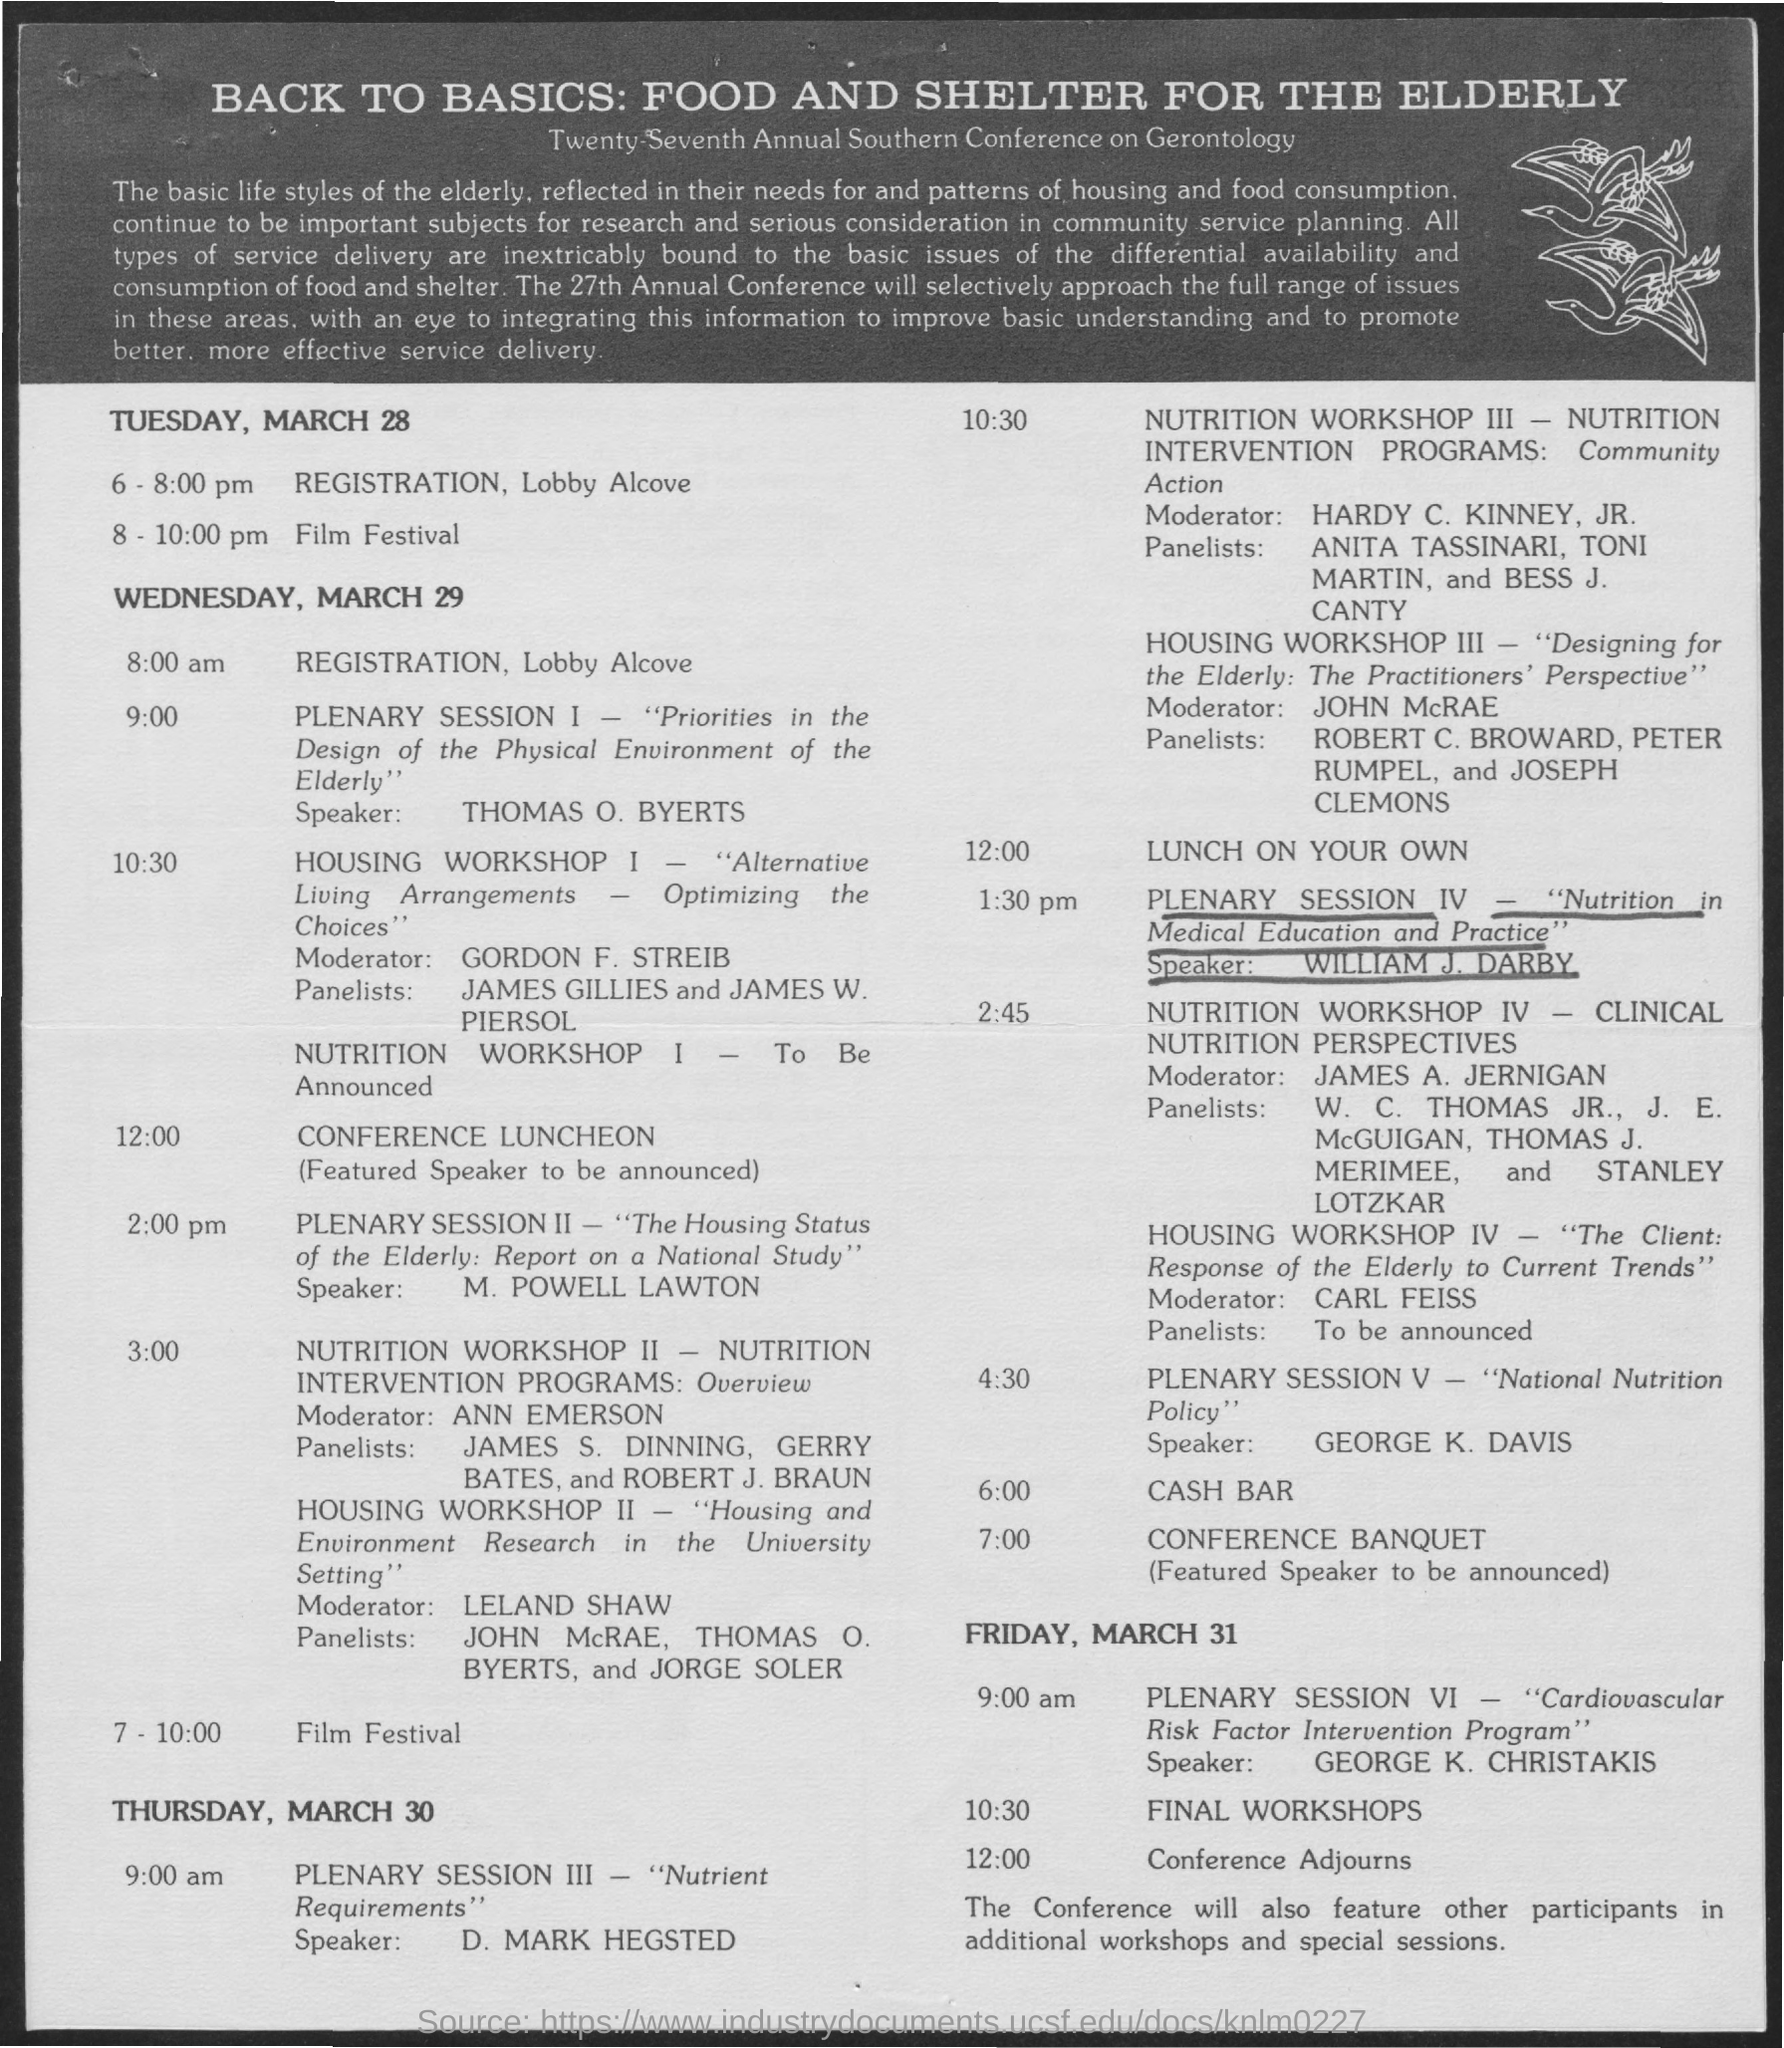When is the Registration for Tuesday, March 28?
Your answer should be very brief. 6 - 8:00 pm. When is the Film Festival on Tuesday, March 28?
Your answer should be very brief. 8 - 10:00 pm. When is the Registration for Wednesday, March 29?
Your answer should be very brief. 8:00 am. When is the conference banquette?
Give a very brief answer. 7:00. 